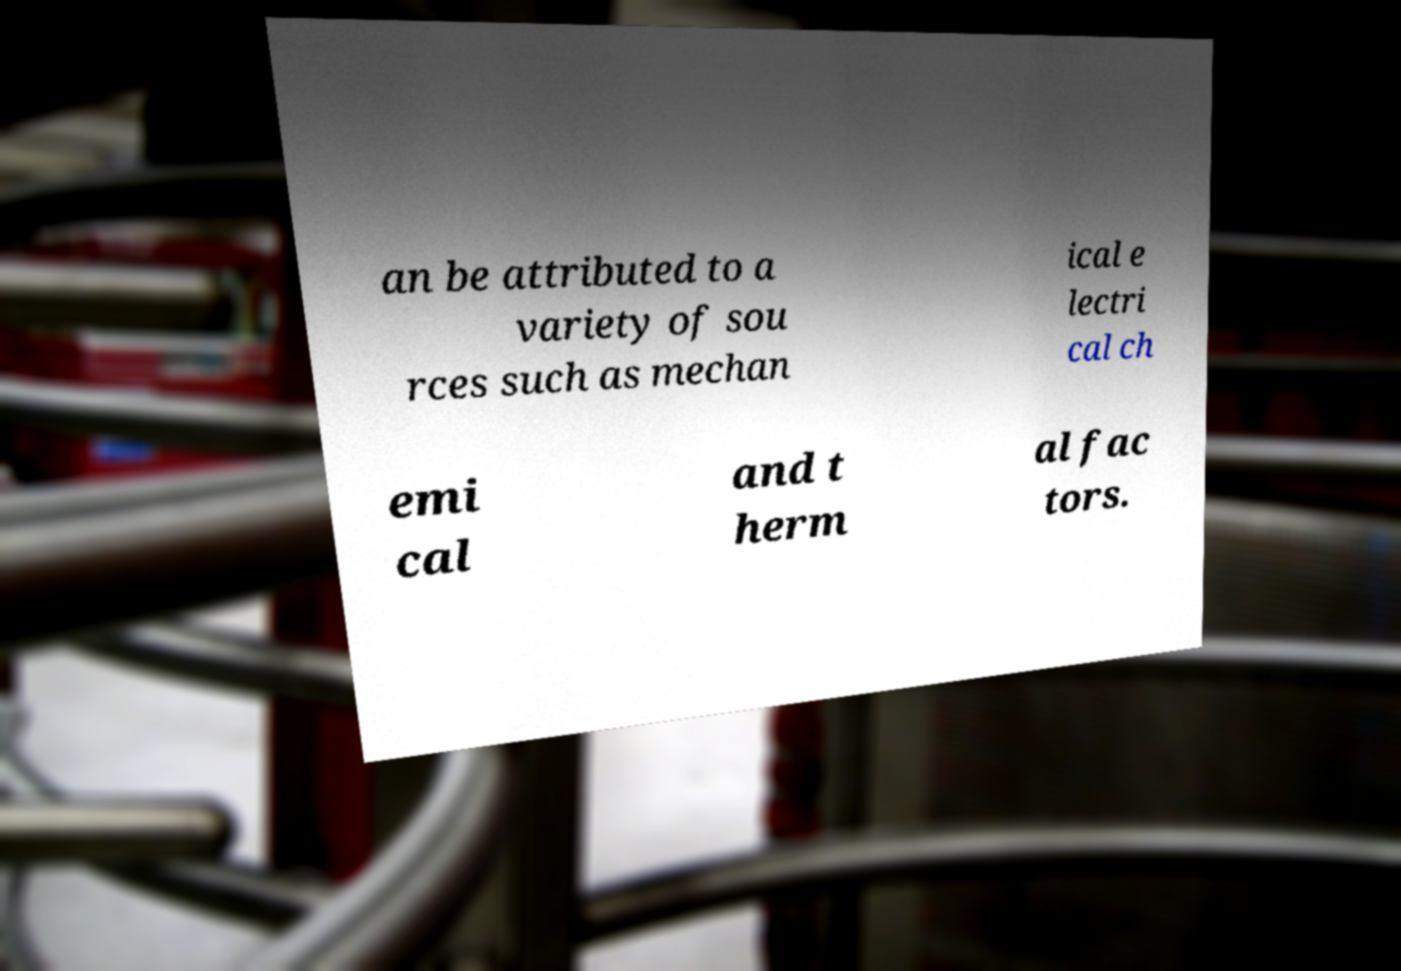There's text embedded in this image that I need extracted. Can you transcribe it verbatim? an be attributed to a variety of sou rces such as mechan ical e lectri cal ch emi cal and t herm al fac tors. 